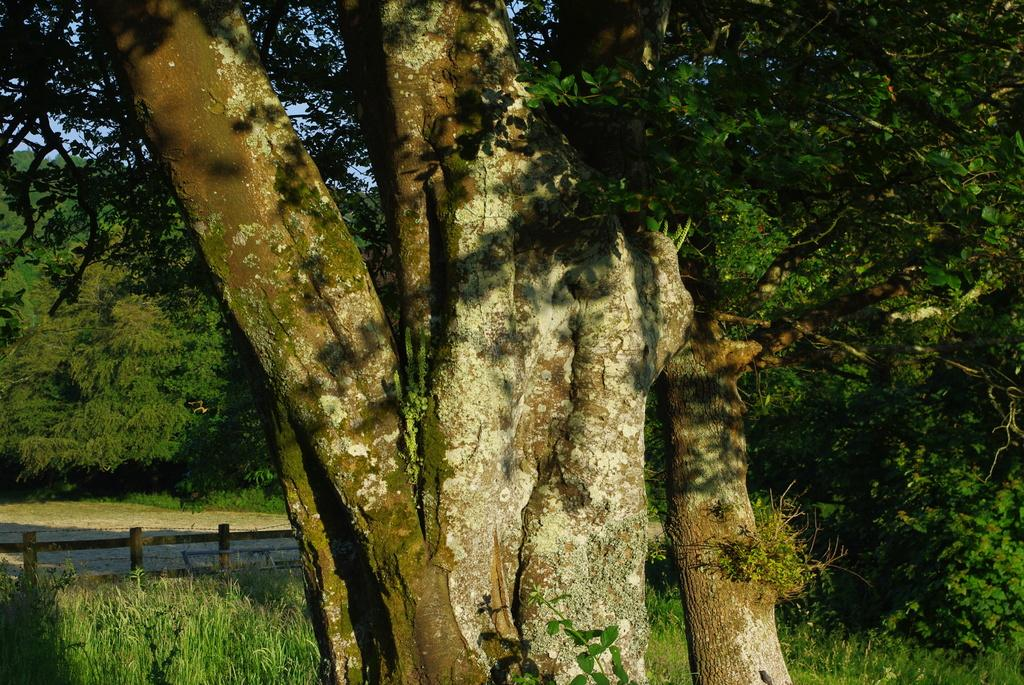What is a natural element visible in the image? The sky is visible in the image. What type of vegetation can be seen in the image? There are trees and plants in the image. What is the ground covered with in the image? Grass is present in the image. What type of barrier is in the image? There is a fence in the image. What type of music can be heard playing in the background of the image? There is no music present in the image, as it is a still photograph. What type of form is the baseball taking in the image? There is no baseball present in the image. 